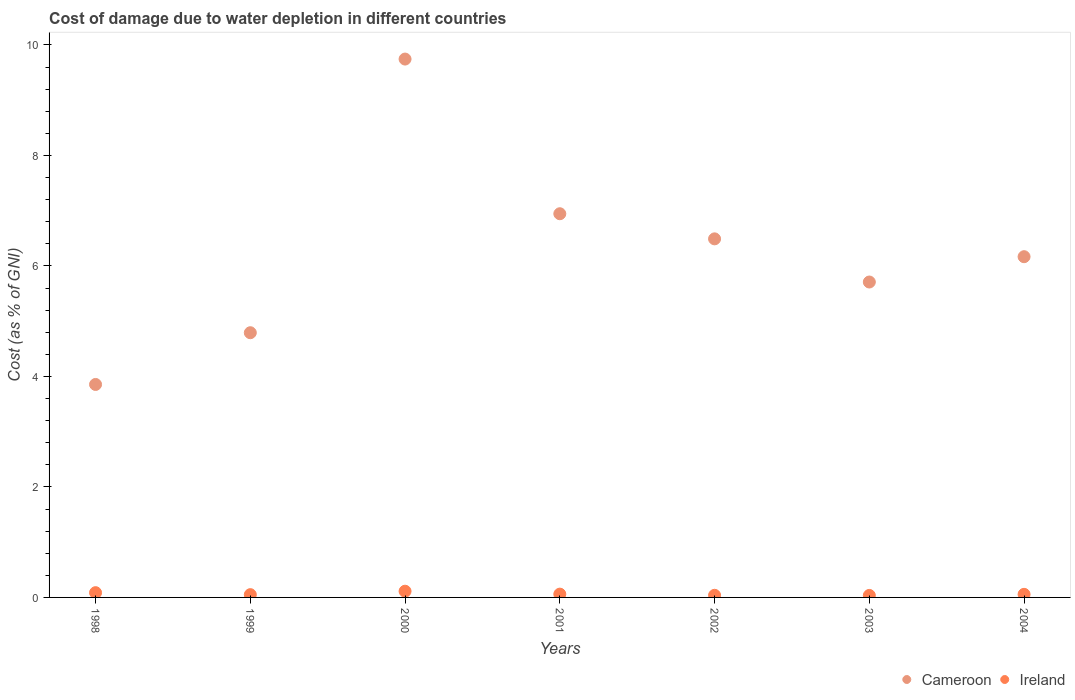Is the number of dotlines equal to the number of legend labels?
Offer a very short reply. Yes. What is the cost of damage caused due to water depletion in Ireland in 2000?
Offer a very short reply. 0.11. Across all years, what is the maximum cost of damage caused due to water depletion in Ireland?
Provide a short and direct response. 0.11. Across all years, what is the minimum cost of damage caused due to water depletion in Ireland?
Offer a very short reply. 0.04. In which year was the cost of damage caused due to water depletion in Ireland minimum?
Offer a terse response. 2003. What is the total cost of damage caused due to water depletion in Ireland in the graph?
Your response must be concise. 0.44. What is the difference between the cost of damage caused due to water depletion in Cameroon in 2001 and that in 2004?
Make the answer very short. 0.78. What is the difference between the cost of damage caused due to water depletion in Cameroon in 2002 and the cost of damage caused due to water depletion in Ireland in 1999?
Your answer should be very brief. 6.44. What is the average cost of damage caused due to water depletion in Ireland per year?
Provide a succinct answer. 0.06. In the year 2000, what is the difference between the cost of damage caused due to water depletion in Cameroon and cost of damage caused due to water depletion in Ireland?
Offer a terse response. 9.63. In how many years, is the cost of damage caused due to water depletion in Cameroon greater than 1.6 %?
Your answer should be very brief. 7. What is the ratio of the cost of damage caused due to water depletion in Ireland in 2000 to that in 2003?
Provide a succinct answer. 3.1. What is the difference between the highest and the second highest cost of damage caused due to water depletion in Cameroon?
Provide a succinct answer. 2.8. What is the difference between the highest and the lowest cost of damage caused due to water depletion in Cameroon?
Make the answer very short. 5.89. In how many years, is the cost of damage caused due to water depletion in Cameroon greater than the average cost of damage caused due to water depletion in Cameroon taken over all years?
Provide a succinct answer. 3. Is the sum of the cost of damage caused due to water depletion in Ireland in 1999 and 2004 greater than the maximum cost of damage caused due to water depletion in Cameroon across all years?
Your answer should be very brief. No. Does the cost of damage caused due to water depletion in Ireland monotonically increase over the years?
Give a very brief answer. No. Is the cost of damage caused due to water depletion in Cameroon strictly less than the cost of damage caused due to water depletion in Ireland over the years?
Give a very brief answer. No. What is the difference between two consecutive major ticks on the Y-axis?
Keep it short and to the point. 2. Does the graph contain any zero values?
Offer a very short reply. No. What is the title of the graph?
Offer a terse response. Cost of damage due to water depletion in different countries. What is the label or title of the X-axis?
Make the answer very short. Years. What is the label or title of the Y-axis?
Make the answer very short. Cost (as % of GNI). What is the Cost (as % of GNI) in Cameroon in 1998?
Your answer should be compact. 3.85. What is the Cost (as % of GNI) in Ireland in 1998?
Provide a succinct answer. 0.09. What is the Cost (as % of GNI) in Cameroon in 1999?
Your answer should be compact. 4.79. What is the Cost (as % of GNI) of Ireland in 1999?
Ensure brevity in your answer.  0.05. What is the Cost (as % of GNI) of Cameroon in 2000?
Offer a terse response. 9.74. What is the Cost (as % of GNI) in Ireland in 2000?
Your response must be concise. 0.11. What is the Cost (as % of GNI) in Cameroon in 2001?
Offer a very short reply. 6.94. What is the Cost (as % of GNI) in Ireland in 2001?
Keep it short and to the point. 0.06. What is the Cost (as % of GNI) in Cameroon in 2002?
Provide a succinct answer. 6.49. What is the Cost (as % of GNI) of Ireland in 2002?
Keep it short and to the point. 0.04. What is the Cost (as % of GNI) of Cameroon in 2003?
Keep it short and to the point. 5.71. What is the Cost (as % of GNI) in Ireland in 2003?
Ensure brevity in your answer.  0.04. What is the Cost (as % of GNI) of Cameroon in 2004?
Give a very brief answer. 6.17. What is the Cost (as % of GNI) of Ireland in 2004?
Your answer should be very brief. 0.06. Across all years, what is the maximum Cost (as % of GNI) in Cameroon?
Your response must be concise. 9.74. Across all years, what is the maximum Cost (as % of GNI) of Ireland?
Your answer should be very brief. 0.11. Across all years, what is the minimum Cost (as % of GNI) of Cameroon?
Make the answer very short. 3.85. Across all years, what is the minimum Cost (as % of GNI) in Ireland?
Keep it short and to the point. 0.04. What is the total Cost (as % of GNI) in Cameroon in the graph?
Provide a short and direct response. 43.7. What is the total Cost (as % of GNI) in Ireland in the graph?
Your response must be concise. 0.44. What is the difference between the Cost (as % of GNI) of Cameroon in 1998 and that in 1999?
Give a very brief answer. -0.94. What is the difference between the Cost (as % of GNI) in Ireland in 1998 and that in 1999?
Your answer should be very brief. 0.04. What is the difference between the Cost (as % of GNI) of Cameroon in 1998 and that in 2000?
Your response must be concise. -5.89. What is the difference between the Cost (as % of GNI) in Ireland in 1998 and that in 2000?
Give a very brief answer. -0.03. What is the difference between the Cost (as % of GNI) of Cameroon in 1998 and that in 2001?
Provide a succinct answer. -3.09. What is the difference between the Cost (as % of GNI) in Ireland in 1998 and that in 2001?
Offer a terse response. 0.03. What is the difference between the Cost (as % of GNI) in Cameroon in 1998 and that in 2002?
Ensure brevity in your answer.  -2.64. What is the difference between the Cost (as % of GNI) in Ireland in 1998 and that in 2002?
Your answer should be compact. 0.05. What is the difference between the Cost (as % of GNI) of Cameroon in 1998 and that in 2003?
Your answer should be very brief. -1.85. What is the difference between the Cost (as % of GNI) in Ireland in 1998 and that in 2003?
Provide a short and direct response. 0.05. What is the difference between the Cost (as % of GNI) in Cameroon in 1998 and that in 2004?
Ensure brevity in your answer.  -2.31. What is the difference between the Cost (as % of GNI) in Ireland in 1998 and that in 2004?
Offer a terse response. 0.03. What is the difference between the Cost (as % of GNI) of Cameroon in 1999 and that in 2000?
Your response must be concise. -4.95. What is the difference between the Cost (as % of GNI) of Ireland in 1999 and that in 2000?
Your answer should be very brief. -0.06. What is the difference between the Cost (as % of GNI) of Cameroon in 1999 and that in 2001?
Offer a very short reply. -2.15. What is the difference between the Cost (as % of GNI) in Ireland in 1999 and that in 2001?
Give a very brief answer. -0.01. What is the difference between the Cost (as % of GNI) of Cameroon in 1999 and that in 2002?
Provide a succinct answer. -1.7. What is the difference between the Cost (as % of GNI) in Ireland in 1999 and that in 2002?
Your answer should be compact. 0.01. What is the difference between the Cost (as % of GNI) of Cameroon in 1999 and that in 2003?
Offer a very short reply. -0.92. What is the difference between the Cost (as % of GNI) in Ireland in 1999 and that in 2003?
Provide a succinct answer. 0.01. What is the difference between the Cost (as % of GNI) in Cameroon in 1999 and that in 2004?
Provide a short and direct response. -1.38. What is the difference between the Cost (as % of GNI) in Ireland in 1999 and that in 2004?
Give a very brief answer. -0.01. What is the difference between the Cost (as % of GNI) of Cameroon in 2000 and that in 2001?
Make the answer very short. 2.8. What is the difference between the Cost (as % of GNI) in Ireland in 2000 and that in 2001?
Offer a very short reply. 0.05. What is the difference between the Cost (as % of GNI) of Cameroon in 2000 and that in 2002?
Your response must be concise. 3.25. What is the difference between the Cost (as % of GNI) in Ireland in 2000 and that in 2002?
Offer a terse response. 0.07. What is the difference between the Cost (as % of GNI) in Cameroon in 2000 and that in 2003?
Offer a terse response. 4.04. What is the difference between the Cost (as % of GNI) of Ireland in 2000 and that in 2003?
Provide a short and direct response. 0.08. What is the difference between the Cost (as % of GNI) in Cameroon in 2000 and that in 2004?
Offer a terse response. 3.58. What is the difference between the Cost (as % of GNI) of Ireland in 2000 and that in 2004?
Your answer should be very brief. 0.06. What is the difference between the Cost (as % of GNI) in Cameroon in 2001 and that in 2002?
Provide a succinct answer. 0.45. What is the difference between the Cost (as % of GNI) in Ireland in 2001 and that in 2002?
Offer a terse response. 0.02. What is the difference between the Cost (as % of GNI) in Cameroon in 2001 and that in 2003?
Make the answer very short. 1.24. What is the difference between the Cost (as % of GNI) in Ireland in 2001 and that in 2003?
Make the answer very short. 0.02. What is the difference between the Cost (as % of GNI) of Cameroon in 2001 and that in 2004?
Offer a terse response. 0.78. What is the difference between the Cost (as % of GNI) of Ireland in 2001 and that in 2004?
Provide a short and direct response. 0. What is the difference between the Cost (as % of GNI) of Cameroon in 2002 and that in 2003?
Keep it short and to the point. 0.78. What is the difference between the Cost (as % of GNI) of Ireland in 2002 and that in 2003?
Keep it short and to the point. 0. What is the difference between the Cost (as % of GNI) in Cameroon in 2002 and that in 2004?
Your answer should be very brief. 0.32. What is the difference between the Cost (as % of GNI) of Ireland in 2002 and that in 2004?
Provide a succinct answer. -0.02. What is the difference between the Cost (as % of GNI) in Cameroon in 2003 and that in 2004?
Offer a very short reply. -0.46. What is the difference between the Cost (as % of GNI) of Ireland in 2003 and that in 2004?
Make the answer very short. -0.02. What is the difference between the Cost (as % of GNI) in Cameroon in 1998 and the Cost (as % of GNI) in Ireland in 1999?
Make the answer very short. 3.8. What is the difference between the Cost (as % of GNI) in Cameroon in 1998 and the Cost (as % of GNI) in Ireland in 2000?
Your response must be concise. 3.74. What is the difference between the Cost (as % of GNI) in Cameroon in 1998 and the Cost (as % of GNI) in Ireland in 2001?
Provide a succinct answer. 3.79. What is the difference between the Cost (as % of GNI) of Cameroon in 1998 and the Cost (as % of GNI) of Ireland in 2002?
Give a very brief answer. 3.82. What is the difference between the Cost (as % of GNI) of Cameroon in 1998 and the Cost (as % of GNI) of Ireland in 2003?
Your answer should be compact. 3.82. What is the difference between the Cost (as % of GNI) of Cameroon in 1998 and the Cost (as % of GNI) of Ireland in 2004?
Keep it short and to the point. 3.8. What is the difference between the Cost (as % of GNI) in Cameroon in 1999 and the Cost (as % of GNI) in Ireland in 2000?
Your response must be concise. 4.68. What is the difference between the Cost (as % of GNI) in Cameroon in 1999 and the Cost (as % of GNI) in Ireland in 2001?
Your answer should be very brief. 4.73. What is the difference between the Cost (as % of GNI) of Cameroon in 1999 and the Cost (as % of GNI) of Ireland in 2002?
Keep it short and to the point. 4.75. What is the difference between the Cost (as % of GNI) in Cameroon in 1999 and the Cost (as % of GNI) in Ireland in 2003?
Provide a succinct answer. 4.75. What is the difference between the Cost (as % of GNI) in Cameroon in 1999 and the Cost (as % of GNI) in Ireland in 2004?
Make the answer very short. 4.74. What is the difference between the Cost (as % of GNI) of Cameroon in 2000 and the Cost (as % of GNI) of Ireland in 2001?
Your answer should be very brief. 9.68. What is the difference between the Cost (as % of GNI) of Cameroon in 2000 and the Cost (as % of GNI) of Ireland in 2002?
Provide a short and direct response. 9.71. What is the difference between the Cost (as % of GNI) of Cameroon in 2000 and the Cost (as % of GNI) of Ireland in 2003?
Give a very brief answer. 9.71. What is the difference between the Cost (as % of GNI) in Cameroon in 2000 and the Cost (as % of GNI) in Ireland in 2004?
Your answer should be compact. 9.69. What is the difference between the Cost (as % of GNI) in Cameroon in 2001 and the Cost (as % of GNI) in Ireland in 2002?
Ensure brevity in your answer.  6.91. What is the difference between the Cost (as % of GNI) in Cameroon in 2001 and the Cost (as % of GNI) in Ireland in 2003?
Your answer should be very brief. 6.91. What is the difference between the Cost (as % of GNI) of Cameroon in 2001 and the Cost (as % of GNI) of Ireland in 2004?
Offer a very short reply. 6.89. What is the difference between the Cost (as % of GNI) of Cameroon in 2002 and the Cost (as % of GNI) of Ireland in 2003?
Offer a terse response. 6.45. What is the difference between the Cost (as % of GNI) in Cameroon in 2002 and the Cost (as % of GNI) in Ireland in 2004?
Your response must be concise. 6.43. What is the difference between the Cost (as % of GNI) in Cameroon in 2003 and the Cost (as % of GNI) in Ireland in 2004?
Provide a succinct answer. 5.65. What is the average Cost (as % of GNI) of Cameroon per year?
Your response must be concise. 6.24. What is the average Cost (as % of GNI) of Ireland per year?
Provide a succinct answer. 0.06. In the year 1998, what is the difference between the Cost (as % of GNI) of Cameroon and Cost (as % of GNI) of Ireland?
Ensure brevity in your answer.  3.77. In the year 1999, what is the difference between the Cost (as % of GNI) in Cameroon and Cost (as % of GNI) in Ireland?
Your answer should be very brief. 4.74. In the year 2000, what is the difference between the Cost (as % of GNI) of Cameroon and Cost (as % of GNI) of Ireland?
Offer a terse response. 9.63. In the year 2001, what is the difference between the Cost (as % of GNI) of Cameroon and Cost (as % of GNI) of Ireland?
Your answer should be very brief. 6.88. In the year 2002, what is the difference between the Cost (as % of GNI) of Cameroon and Cost (as % of GNI) of Ireland?
Your answer should be compact. 6.45. In the year 2003, what is the difference between the Cost (as % of GNI) in Cameroon and Cost (as % of GNI) in Ireland?
Provide a short and direct response. 5.67. In the year 2004, what is the difference between the Cost (as % of GNI) in Cameroon and Cost (as % of GNI) in Ireland?
Provide a succinct answer. 6.11. What is the ratio of the Cost (as % of GNI) of Cameroon in 1998 to that in 1999?
Your answer should be very brief. 0.8. What is the ratio of the Cost (as % of GNI) of Ireland in 1998 to that in 1999?
Your answer should be compact. 1.72. What is the ratio of the Cost (as % of GNI) of Cameroon in 1998 to that in 2000?
Offer a very short reply. 0.4. What is the ratio of the Cost (as % of GNI) in Ireland in 1998 to that in 2000?
Provide a short and direct response. 0.77. What is the ratio of the Cost (as % of GNI) of Cameroon in 1998 to that in 2001?
Ensure brevity in your answer.  0.56. What is the ratio of the Cost (as % of GNI) in Ireland in 1998 to that in 2001?
Offer a very short reply. 1.44. What is the ratio of the Cost (as % of GNI) in Cameroon in 1998 to that in 2002?
Your answer should be compact. 0.59. What is the ratio of the Cost (as % of GNI) of Ireland in 1998 to that in 2002?
Your response must be concise. 2.23. What is the ratio of the Cost (as % of GNI) in Cameroon in 1998 to that in 2003?
Your response must be concise. 0.68. What is the ratio of the Cost (as % of GNI) in Ireland in 1998 to that in 2003?
Ensure brevity in your answer.  2.38. What is the ratio of the Cost (as % of GNI) of Cameroon in 1998 to that in 2004?
Give a very brief answer. 0.62. What is the ratio of the Cost (as % of GNI) in Ireland in 1998 to that in 2004?
Offer a terse response. 1.54. What is the ratio of the Cost (as % of GNI) in Cameroon in 1999 to that in 2000?
Your response must be concise. 0.49. What is the ratio of the Cost (as % of GNI) of Ireland in 1999 to that in 2000?
Give a very brief answer. 0.45. What is the ratio of the Cost (as % of GNI) of Cameroon in 1999 to that in 2001?
Keep it short and to the point. 0.69. What is the ratio of the Cost (as % of GNI) of Ireland in 1999 to that in 2001?
Offer a very short reply. 0.84. What is the ratio of the Cost (as % of GNI) in Cameroon in 1999 to that in 2002?
Your response must be concise. 0.74. What is the ratio of the Cost (as % of GNI) of Ireland in 1999 to that in 2002?
Make the answer very short. 1.3. What is the ratio of the Cost (as % of GNI) of Cameroon in 1999 to that in 2003?
Make the answer very short. 0.84. What is the ratio of the Cost (as % of GNI) in Ireland in 1999 to that in 2003?
Keep it short and to the point. 1.39. What is the ratio of the Cost (as % of GNI) in Cameroon in 1999 to that in 2004?
Give a very brief answer. 0.78. What is the ratio of the Cost (as % of GNI) of Ireland in 1999 to that in 2004?
Make the answer very short. 0.9. What is the ratio of the Cost (as % of GNI) in Cameroon in 2000 to that in 2001?
Make the answer very short. 1.4. What is the ratio of the Cost (as % of GNI) in Ireland in 2000 to that in 2001?
Keep it short and to the point. 1.88. What is the ratio of the Cost (as % of GNI) of Cameroon in 2000 to that in 2002?
Offer a very short reply. 1.5. What is the ratio of the Cost (as % of GNI) in Ireland in 2000 to that in 2002?
Provide a succinct answer. 2.91. What is the ratio of the Cost (as % of GNI) in Cameroon in 2000 to that in 2003?
Keep it short and to the point. 1.71. What is the ratio of the Cost (as % of GNI) of Ireland in 2000 to that in 2003?
Keep it short and to the point. 3.1. What is the ratio of the Cost (as % of GNI) of Cameroon in 2000 to that in 2004?
Offer a terse response. 1.58. What is the ratio of the Cost (as % of GNI) of Ireland in 2000 to that in 2004?
Provide a short and direct response. 2.01. What is the ratio of the Cost (as % of GNI) of Cameroon in 2001 to that in 2002?
Give a very brief answer. 1.07. What is the ratio of the Cost (as % of GNI) of Ireland in 2001 to that in 2002?
Give a very brief answer. 1.55. What is the ratio of the Cost (as % of GNI) in Cameroon in 2001 to that in 2003?
Offer a terse response. 1.22. What is the ratio of the Cost (as % of GNI) in Ireland in 2001 to that in 2003?
Keep it short and to the point. 1.65. What is the ratio of the Cost (as % of GNI) of Cameroon in 2001 to that in 2004?
Your answer should be compact. 1.13. What is the ratio of the Cost (as % of GNI) in Ireland in 2001 to that in 2004?
Your answer should be compact. 1.07. What is the ratio of the Cost (as % of GNI) in Cameroon in 2002 to that in 2003?
Your response must be concise. 1.14. What is the ratio of the Cost (as % of GNI) in Ireland in 2002 to that in 2003?
Provide a succinct answer. 1.07. What is the ratio of the Cost (as % of GNI) of Cameroon in 2002 to that in 2004?
Offer a very short reply. 1.05. What is the ratio of the Cost (as % of GNI) in Ireland in 2002 to that in 2004?
Give a very brief answer. 0.69. What is the ratio of the Cost (as % of GNI) of Cameroon in 2003 to that in 2004?
Offer a terse response. 0.93. What is the ratio of the Cost (as % of GNI) in Ireland in 2003 to that in 2004?
Ensure brevity in your answer.  0.65. What is the difference between the highest and the second highest Cost (as % of GNI) of Cameroon?
Offer a terse response. 2.8. What is the difference between the highest and the second highest Cost (as % of GNI) in Ireland?
Your answer should be compact. 0.03. What is the difference between the highest and the lowest Cost (as % of GNI) of Cameroon?
Your answer should be very brief. 5.89. What is the difference between the highest and the lowest Cost (as % of GNI) of Ireland?
Make the answer very short. 0.08. 